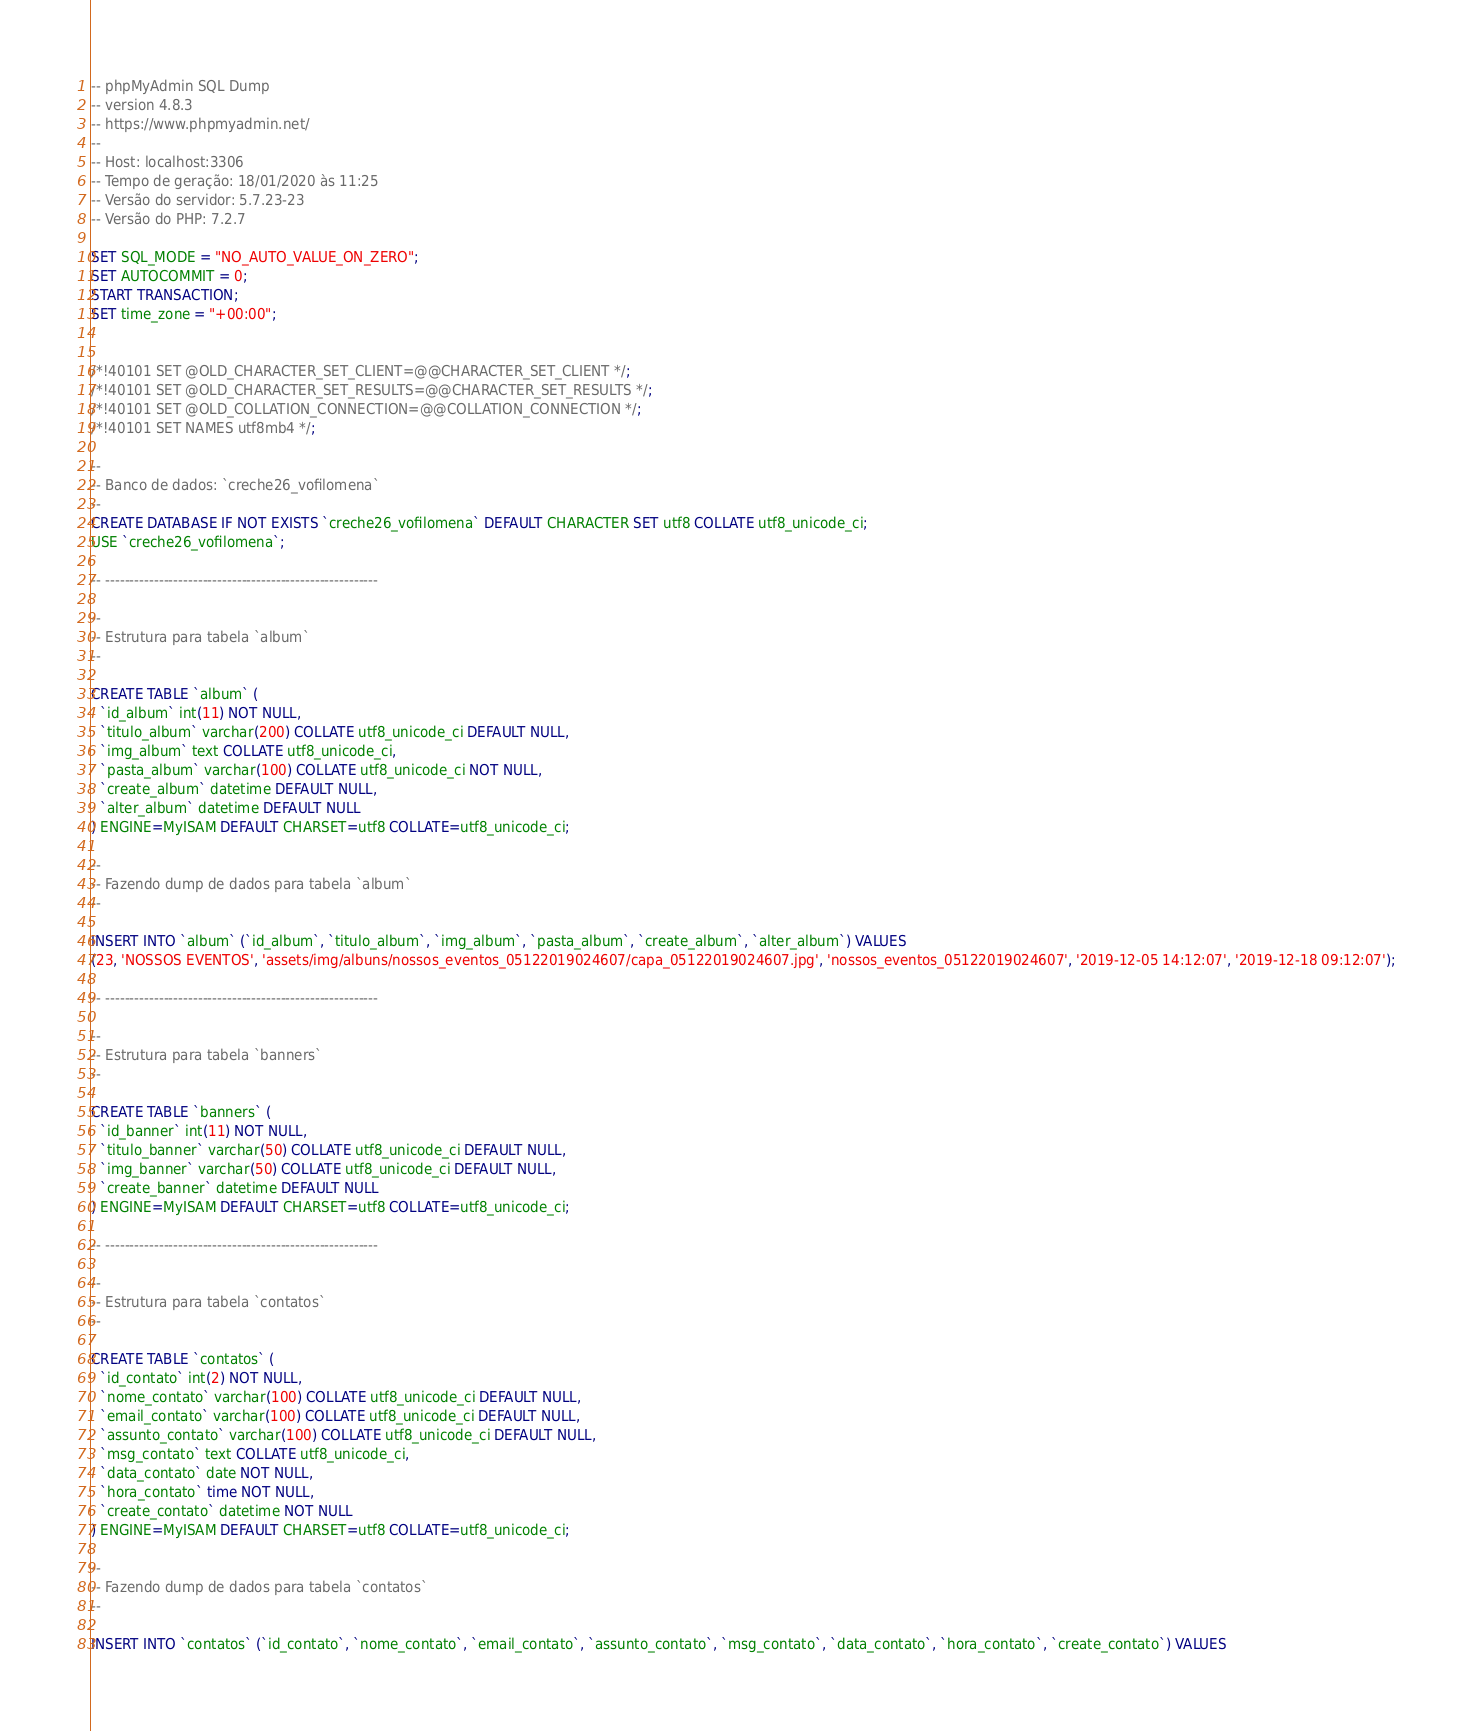Convert code to text. <code><loc_0><loc_0><loc_500><loc_500><_SQL_>-- phpMyAdmin SQL Dump
-- version 4.8.3
-- https://www.phpmyadmin.net/
--
-- Host: localhost:3306
-- Tempo de geração: 18/01/2020 às 11:25
-- Versão do servidor: 5.7.23-23
-- Versão do PHP: 7.2.7

SET SQL_MODE = "NO_AUTO_VALUE_ON_ZERO";
SET AUTOCOMMIT = 0;
START TRANSACTION;
SET time_zone = "+00:00";


/*!40101 SET @OLD_CHARACTER_SET_CLIENT=@@CHARACTER_SET_CLIENT */;
/*!40101 SET @OLD_CHARACTER_SET_RESULTS=@@CHARACTER_SET_RESULTS */;
/*!40101 SET @OLD_COLLATION_CONNECTION=@@COLLATION_CONNECTION */;
/*!40101 SET NAMES utf8mb4 */;

--
-- Banco de dados: `creche26_vofilomena`
--
CREATE DATABASE IF NOT EXISTS `creche26_vofilomena` DEFAULT CHARACTER SET utf8 COLLATE utf8_unicode_ci;
USE `creche26_vofilomena`;

-- --------------------------------------------------------

--
-- Estrutura para tabela `album`
--

CREATE TABLE `album` (
  `id_album` int(11) NOT NULL,
  `titulo_album` varchar(200) COLLATE utf8_unicode_ci DEFAULT NULL,
  `img_album` text COLLATE utf8_unicode_ci,
  `pasta_album` varchar(100) COLLATE utf8_unicode_ci NOT NULL,
  `create_album` datetime DEFAULT NULL,
  `alter_album` datetime DEFAULT NULL
) ENGINE=MyISAM DEFAULT CHARSET=utf8 COLLATE=utf8_unicode_ci;

--
-- Fazendo dump de dados para tabela `album`
--

INSERT INTO `album` (`id_album`, `titulo_album`, `img_album`, `pasta_album`, `create_album`, `alter_album`) VALUES
(23, 'NOSSOS EVENTOS', 'assets/img/albuns/nossos_eventos_05122019024607/capa_05122019024607.jpg', 'nossos_eventos_05122019024607', '2019-12-05 14:12:07', '2019-12-18 09:12:07');

-- --------------------------------------------------------

--
-- Estrutura para tabela `banners`
--

CREATE TABLE `banners` (
  `id_banner` int(11) NOT NULL,
  `titulo_banner` varchar(50) COLLATE utf8_unicode_ci DEFAULT NULL,
  `img_banner` varchar(50) COLLATE utf8_unicode_ci DEFAULT NULL,
  `create_banner` datetime DEFAULT NULL
) ENGINE=MyISAM DEFAULT CHARSET=utf8 COLLATE=utf8_unicode_ci;

-- --------------------------------------------------------

--
-- Estrutura para tabela `contatos`
--

CREATE TABLE `contatos` (
  `id_contato` int(2) NOT NULL,
  `nome_contato` varchar(100) COLLATE utf8_unicode_ci DEFAULT NULL,
  `email_contato` varchar(100) COLLATE utf8_unicode_ci DEFAULT NULL,
  `assunto_contato` varchar(100) COLLATE utf8_unicode_ci DEFAULT NULL,
  `msg_contato` text COLLATE utf8_unicode_ci,
  `data_contato` date NOT NULL,
  `hora_contato` time NOT NULL,
  `create_contato` datetime NOT NULL
) ENGINE=MyISAM DEFAULT CHARSET=utf8 COLLATE=utf8_unicode_ci;

--
-- Fazendo dump de dados para tabela `contatos`
--

INSERT INTO `contatos` (`id_contato`, `nome_contato`, `email_contato`, `assunto_contato`, `msg_contato`, `data_contato`, `hora_contato`, `create_contato`) VALUES</code> 